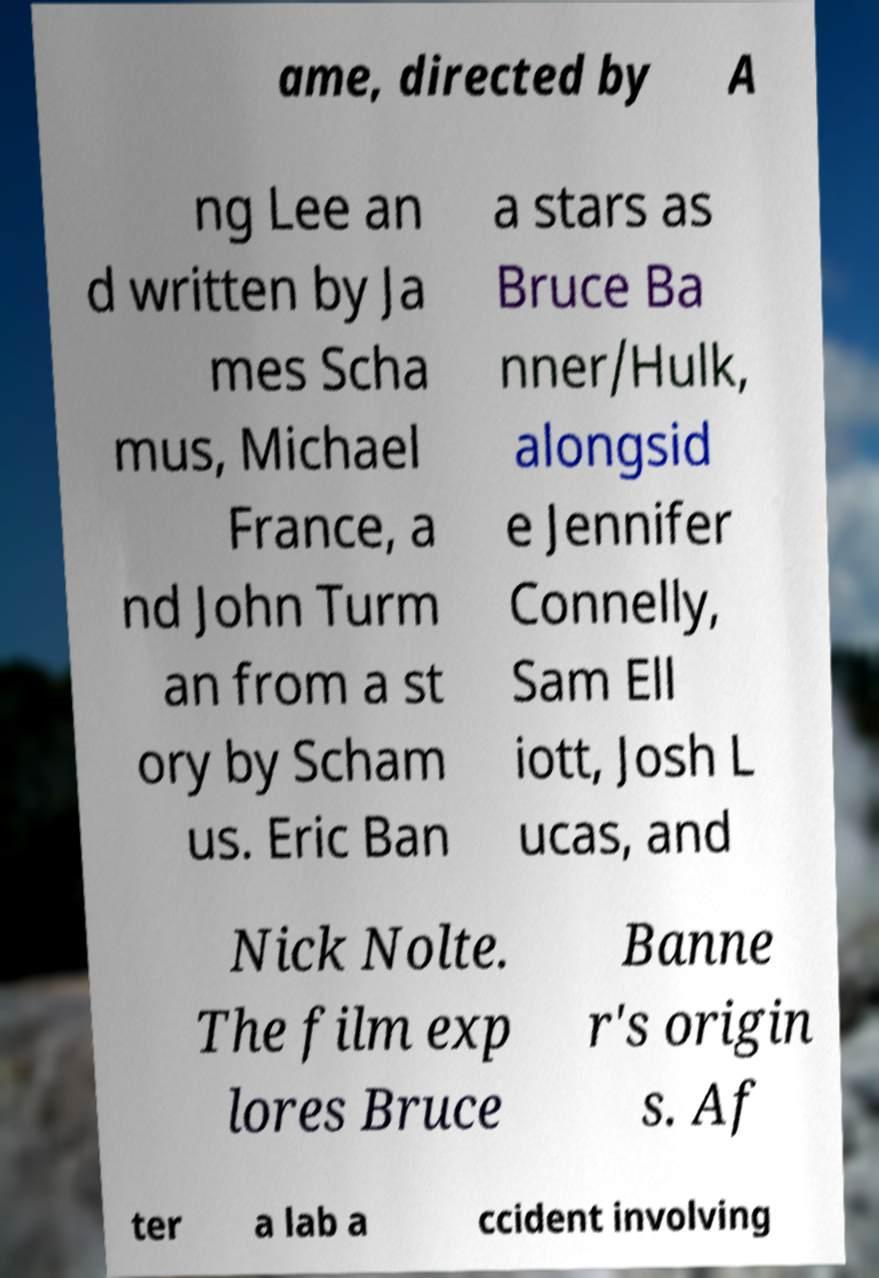Could you extract and type out the text from this image? ame, directed by A ng Lee an d written by Ja mes Scha mus, Michael France, a nd John Turm an from a st ory by Scham us. Eric Ban a stars as Bruce Ba nner/Hulk, alongsid e Jennifer Connelly, Sam Ell iott, Josh L ucas, and Nick Nolte. The film exp lores Bruce Banne r's origin s. Af ter a lab a ccident involving 